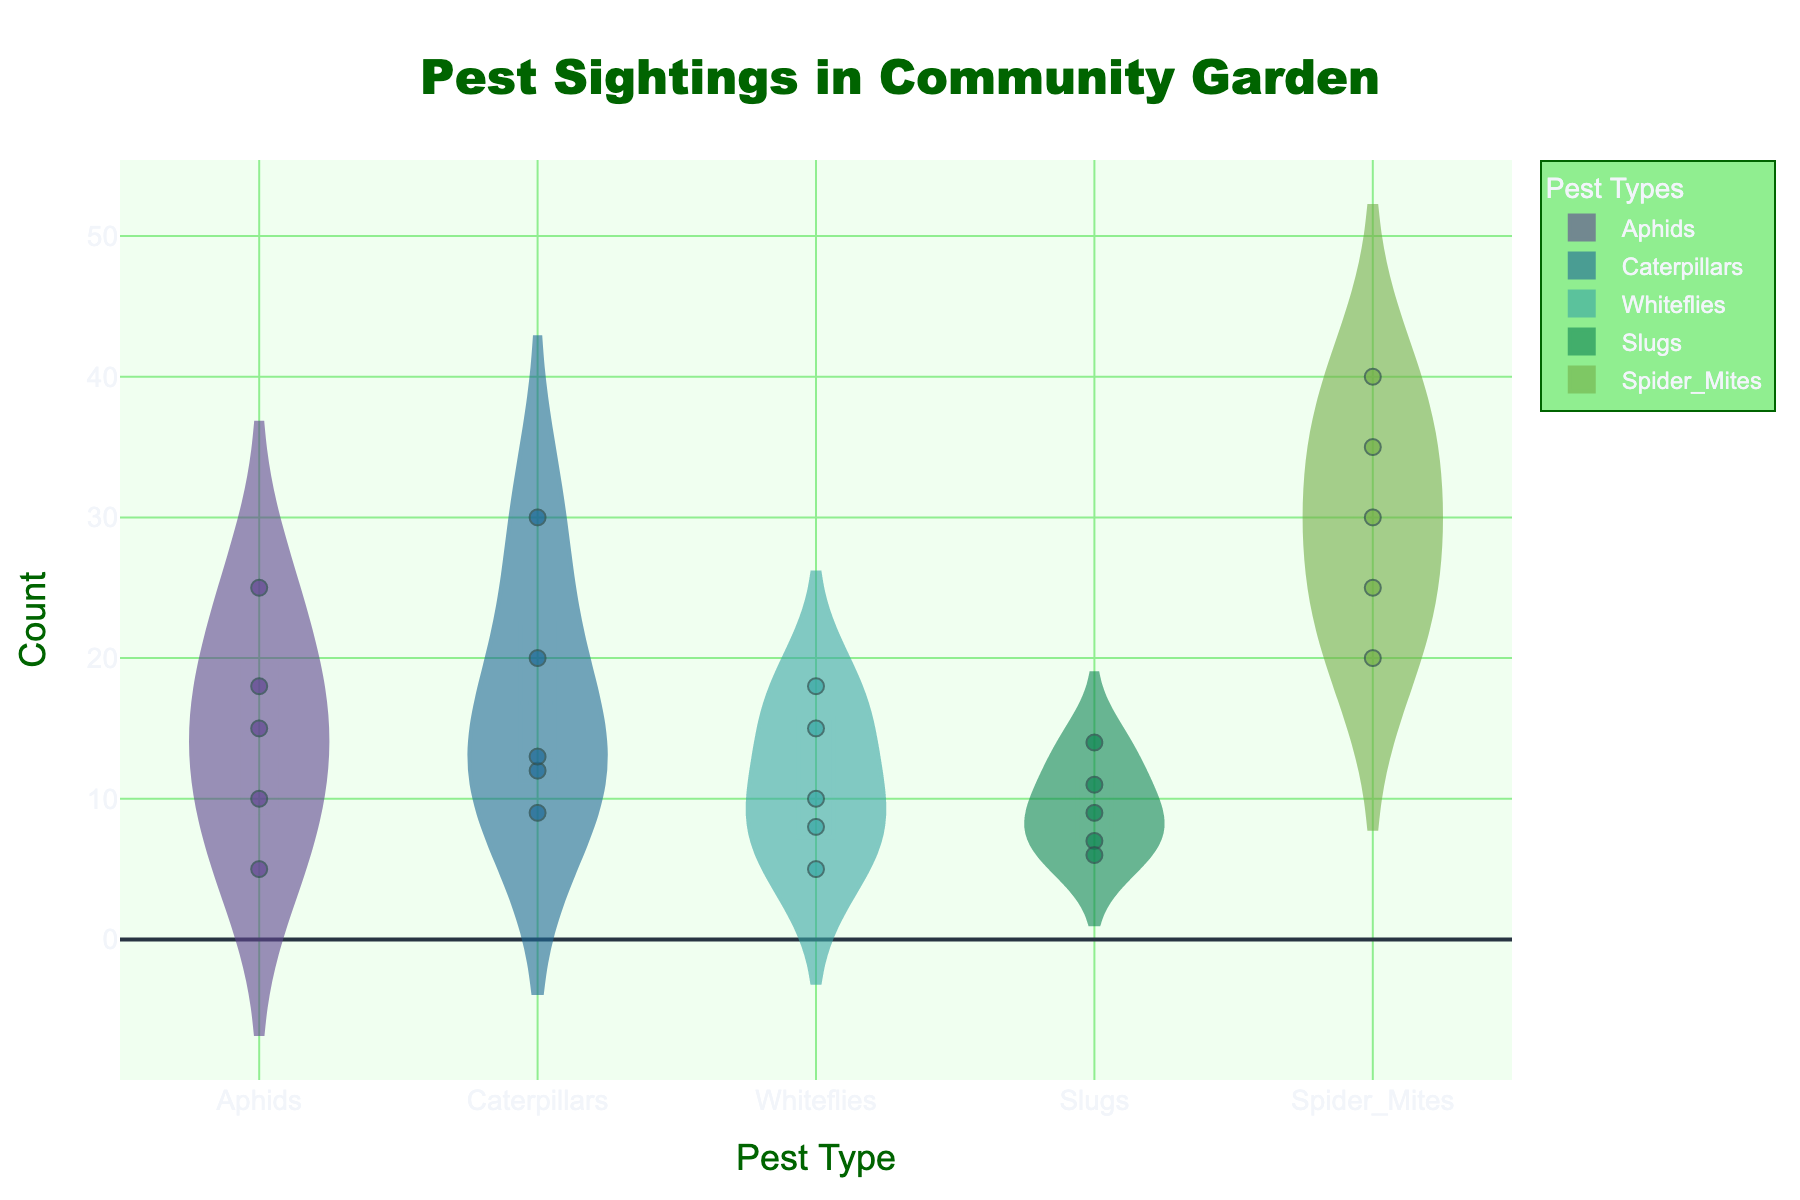Which pest type has the highest mean frequency of sightings? By examining the mean line in each violin plot, we can see that Spider_Mites have the highest mean frequency.
Answer: Spider_Mites Which pest type shows the most variability in sighting counts? The width of the violin plot indicates the variability. Spider_Mites have the widest plot, implying the highest variability in sighting counts.
Answer: Spider_Mites What's the median value of sighting counts for Slugs? The violin plot for Slugs shows a box plot in the middle. The line inside the box represents the median value, which is around 10.
Answer: 10 How many sighting counts of Aphids are above 20? By looking at the jittered points for Aphids above the count of 20, we can see that 2 points are above this threshold.
Answer: 2 What is the overall title of the plot? The title is displayed at the top center of the plot, which reads "Pest Sightings in Community Garden."
Answer: Pest Sightings in Community Garden Which pest type has the lowest sighting count? By looking at the jittered points and the lowest end of the violin plots, we can see that Whiteflies and Spider_Mites both have a count as low as 5.
Answer: Whiteflies and Spider_Mites Compare the frequency of sightings between Caterpillars and Whiteflies. Which one has higher, on average? By comparing the mean lines in the violin plots for both Caterpillars and Whiteflies, Caterpillars have a higher mean frequency of sightings.
Answer: Caterpillars What is the color used for the line marking the mean value in the violin plots? Each violin plot has a line representing the mean value; the line is darker but matches the color fill of the plot.
Answer: Match the fill color Are the individual sightings shown on the plot? Yes, the plot includes jittered points representing individual sightings for each pest type.
Answer: Yes Which pest types have sighting counts that exceed 30? By inspecting the jittered points and the tops of the violin plots, Spider_Mites have sighting counts that exceed 30.
Answer: Spider_Mites 